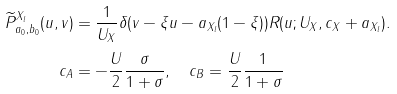Convert formula to latex. <formula><loc_0><loc_0><loc_500><loc_500>\widetilde { P } ^ { X _ { l } } _ { a _ { 0 } , b _ { 0 } } ( u , v ) & = \frac { 1 } { U _ { X } } \delta ( v - \xi u - a _ { X _ { l } } ( 1 - \xi ) ) R ( u ; U _ { X } , c _ { X } + a _ { X _ { l } } ) . \\ c _ { A } & = - \frac { U } { 2 } \frac { \sigma } { 1 + \sigma } , \quad c _ { B } = \frac { U } { 2 } \frac { 1 } { 1 + \sigma }</formula> 